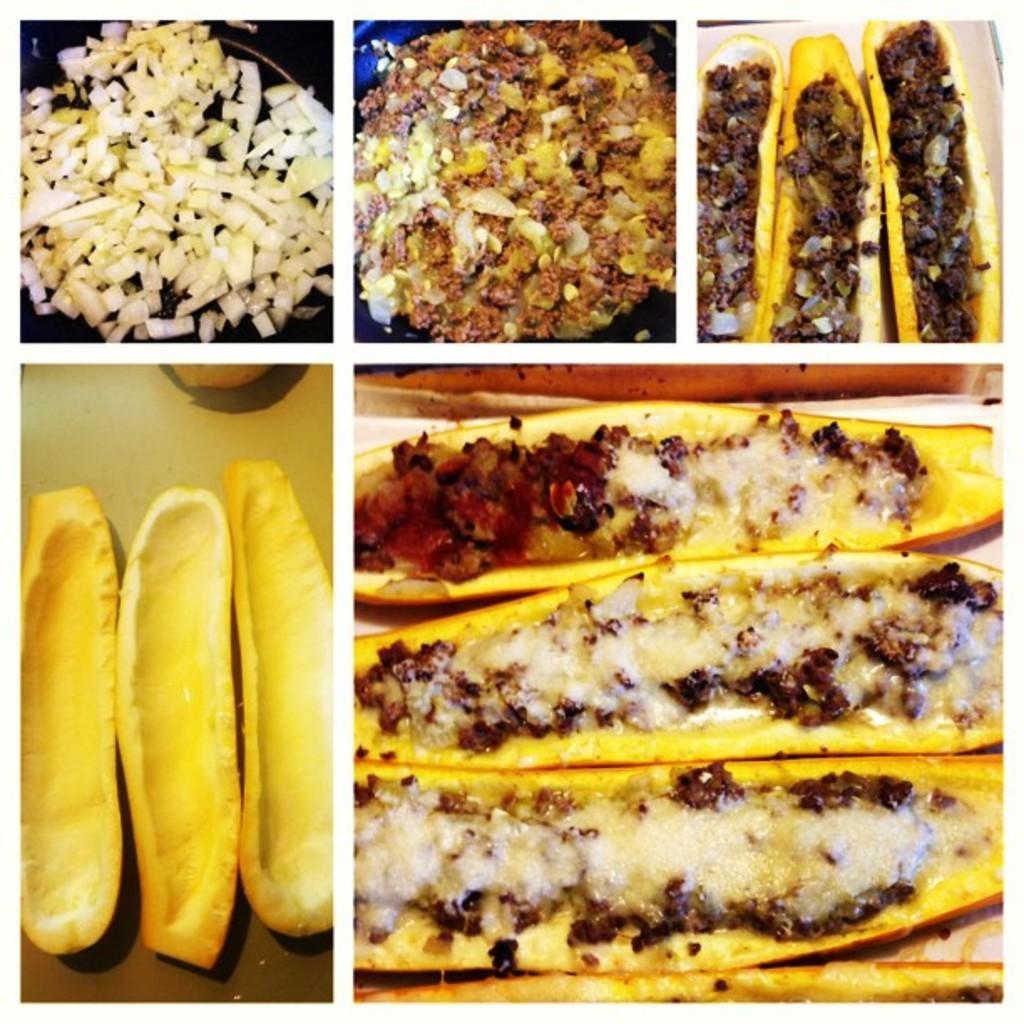How would you summarize this image in a sentence or two? This is a collage picture and in this picture we can see food items and plates. 